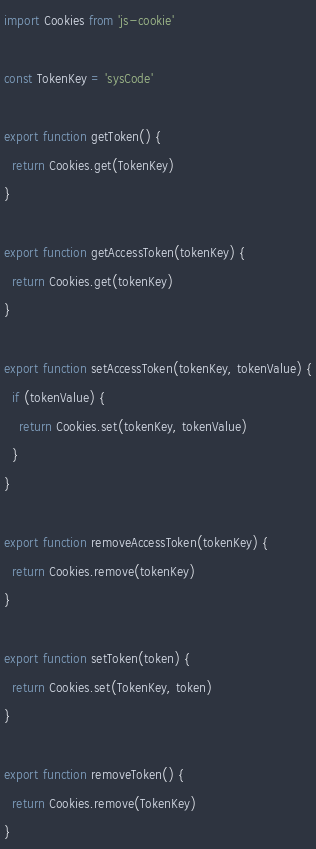<code> <loc_0><loc_0><loc_500><loc_500><_JavaScript_>import Cookies from 'js-cookie'

const TokenKey = 'sysCode'

export function getToken() {
  return Cookies.get(TokenKey)
}

export function getAccessToken(tokenKey) {
  return Cookies.get(tokenKey)
}

export function setAccessToken(tokenKey, tokenValue) {
  if (tokenValue) {
    return Cookies.set(tokenKey, tokenValue)
  }
}

export function removeAccessToken(tokenKey) {
  return Cookies.remove(tokenKey)
}

export function setToken(token) {
  return Cookies.set(TokenKey, token)
}

export function removeToken() {
  return Cookies.remove(TokenKey)
}
</code> 